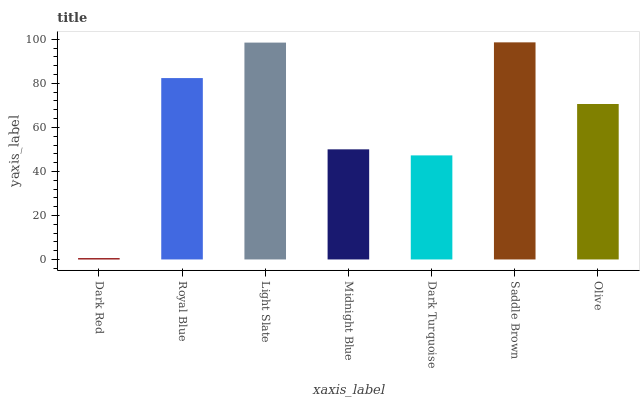Is Dark Red the minimum?
Answer yes or no. Yes. Is Saddle Brown the maximum?
Answer yes or no. Yes. Is Royal Blue the minimum?
Answer yes or no. No. Is Royal Blue the maximum?
Answer yes or no. No. Is Royal Blue greater than Dark Red?
Answer yes or no. Yes. Is Dark Red less than Royal Blue?
Answer yes or no. Yes. Is Dark Red greater than Royal Blue?
Answer yes or no. No. Is Royal Blue less than Dark Red?
Answer yes or no. No. Is Olive the high median?
Answer yes or no. Yes. Is Olive the low median?
Answer yes or no. Yes. Is Dark Turquoise the high median?
Answer yes or no. No. Is Midnight Blue the low median?
Answer yes or no. No. 